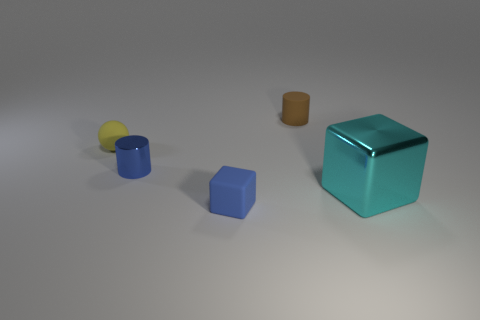Add 3 large brown rubber objects. How many objects exist? 8 Subtract all cubes. How many objects are left? 3 Subtract 0 red cubes. How many objects are left? 5 Subtract all large purple matte cylinders. Subtract all rubber cylinders. How many objects are left? 4 Add 1 metal things. How many metal things are left? 3 Add 3 tiny shiny cylinders. How many tiny shiny cylinders exist? 4 